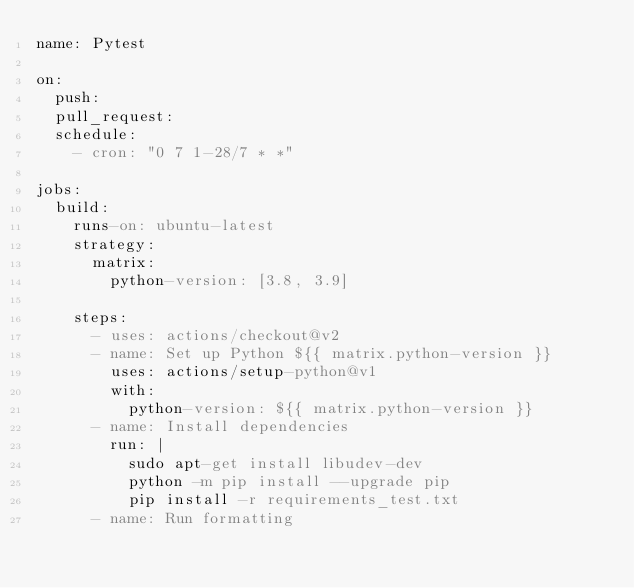Convert code to text. <code><loc_0><loc_0><loc_500><loc_500><_YAML_>name: Pytest

on:
  push:
  pull_request:
  schedule:
    - cron: "0 7 1-28/7 * *"

jobs:
  build:
    runs-on: ubuntu-latest
    strategy:
      matrix:
        python-version: [3.8, 3.9]

    steps:
      - uses: actions/checkout@v2
      - name: Set up Python ${{ matrix.python-version }}
        uses: actions/setup-python@v1
        with:
          python-version: ${{ matrix.python-version }}
      - name: Install dependencies
        run: |
          sudo apt-get install libudev-dev
          python -m pip install --upgrade pip
          pip install -r requirements_test.txt
      - name: Run formatting</code> 